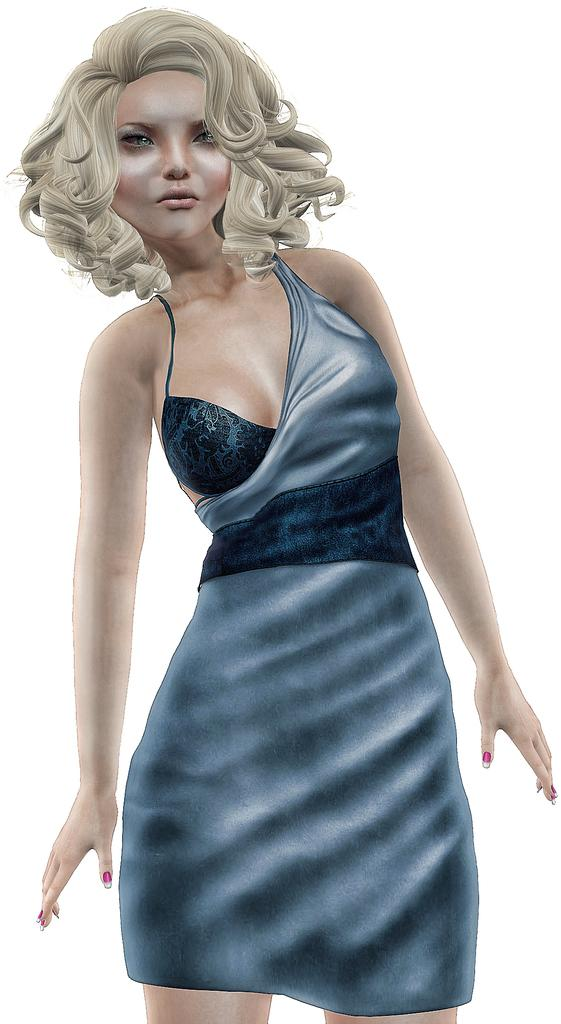What is the main subject of the image? There is a depiction of a woman in the image. What is the woman wearing in the image? The woman is wearing a blue dress in the image. What color is the background of the image? The background of the image is white. What type of wool is the woman using to knit in the image? There is no indication in the image that the woman is knitting or using wool. 